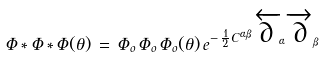<formula> <loc_0><loc_0><loc_500><loc_500>\Phi \ast \Phi \ast \Phi ( \theta ) \, = \, \Phi _ { o } \, \Phi _ { o } \, \Phi _ { o } ( \theta ) \, e ^ { - \, \frac { 1 } { 2 } C ^ { \alpha \beta } \, \overleftarrow { \partial } _ { \alpha } \, \overrightarrow { \partial } _ { \beta } }</formula> 